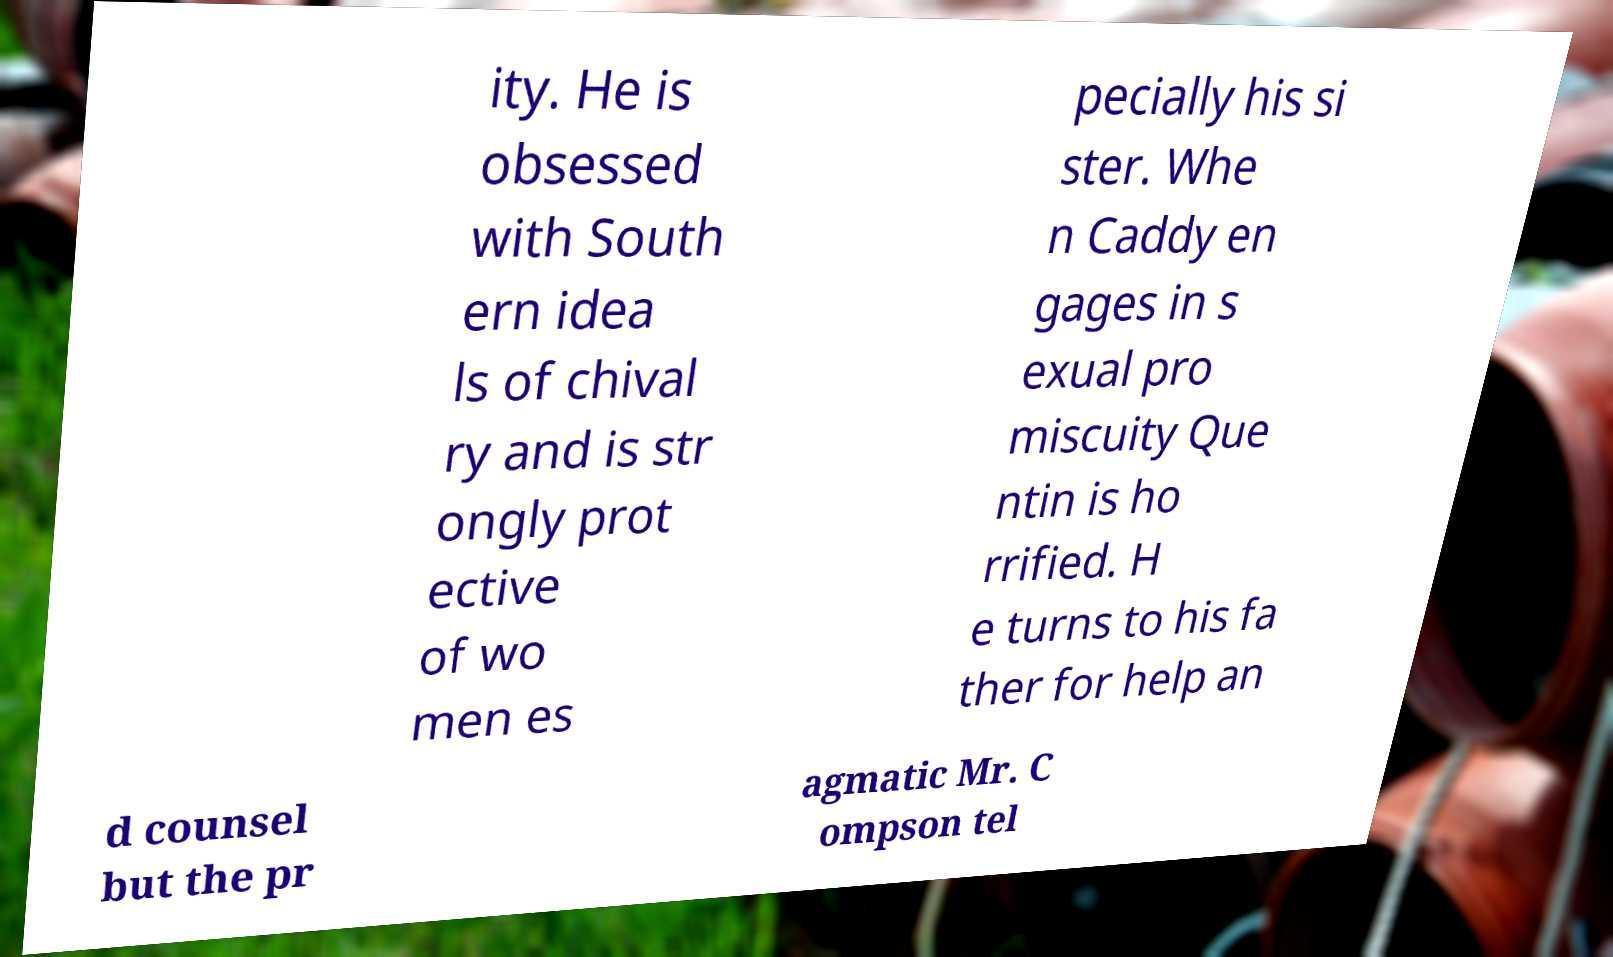Can you read and provide the text displayed in the image?This photo seems to have some interesting text. Can you extract and type it out for me? ity. He is obsessed with South ern idea ls of chival ry and is str ongly prot ective of wo men es pecially his si ster. Whe n Caddy en gages in s exual pro miscuity Que ntin is ho rrified. H e turns to his fa ther for help an d counsel but the pr agmatic Mr. C ompson tel 